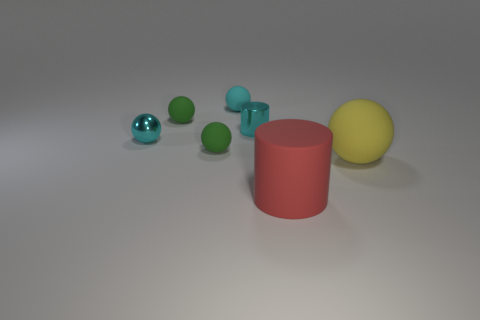Is the shape of the tiny cyan rubber object the same as the object to the right of the large red rubber thing?
Offer a very short reply. Yes. Does the cyan matte thing have the same shape as the large yellow thing?
Give a very brief answer. Yes. What number of small objects are yellow cubes or red rubber things?
Keep it short and to the point. 0. What size is the matte object that is left of the tiny cyan matte ball and behind the small cyan metal cylinder?
Ensure brevity in your answer.  Small. How many cyan balls are behind the yellow matte ball?
Your answer should be compact. 2. There is a thing that is both behind the big red object and right of the small metallic cylinder; what shape is it?
Offer a terse response. Sphere. What is the material of the small cylinder that is the same color as the metal ball?
Ensure brevity in your answer.  Metal. How many balls are tiny metallic objects or tiny matte things?
Your answer should be compact. 4. What is the size of the matte object that is the same color as the small cylinder?
Make the answer very short. Small. Is the number of big matte spheres that are in front of the large red cylinder less than the number of cyan cylinders?
Offer a very short reply. Yes. 